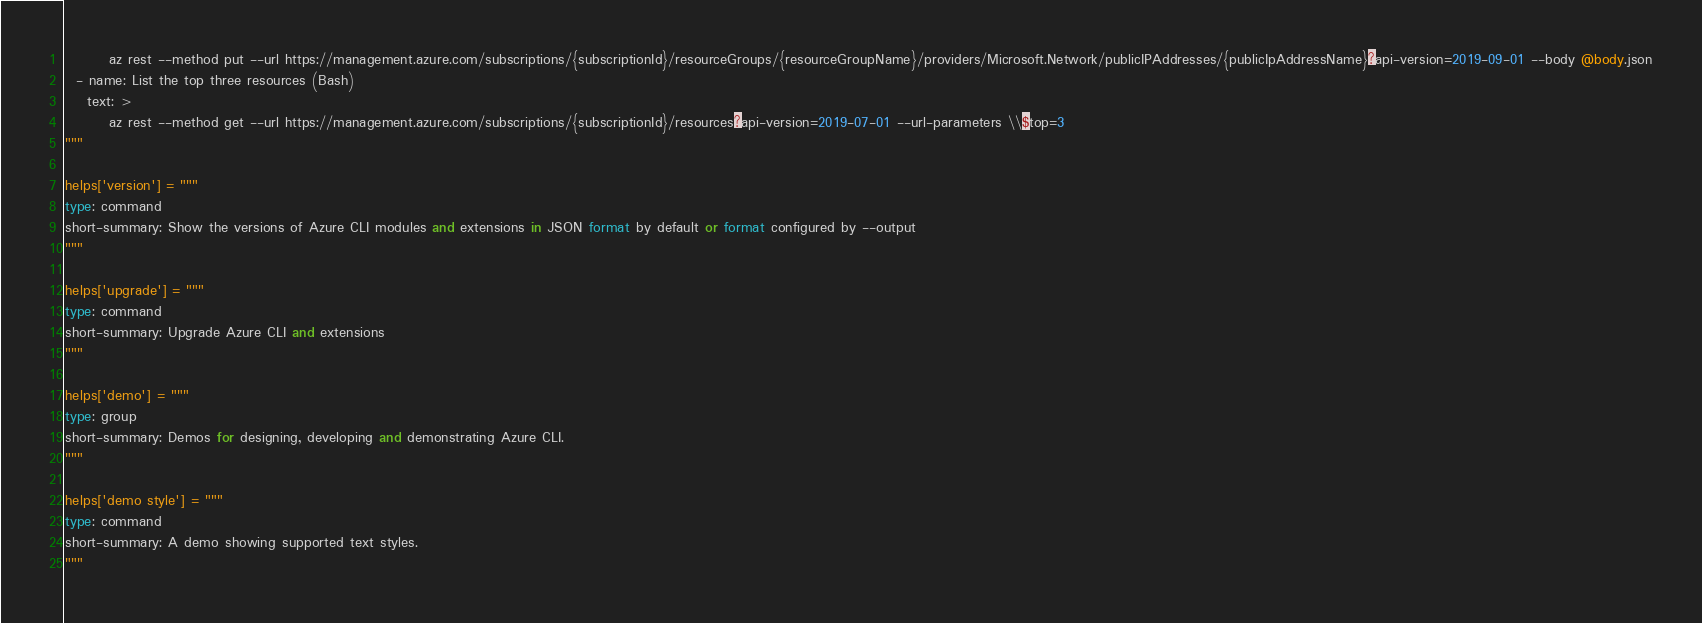<code> <loc_0><loc_0><loc_500><loc_500><_Python_>        az rest --method put --url https://management.azure.com/subscriptions/{subscriptionId}/resourceGroups/{resourceGroupName}/providers/Microsoft.Network/publicIPAddresses/{publicIpAddressName}?api-version=2019-09-01 --body @body.json
  - name: List the top three resources (Bash)
    text: >
        az rest --method get --url https://management.azure.com/subscriptions/{subscriptionId}/resources?api-version=2019-07-01 --url-parameters \\$top=3
"""

helps['version'] = """
type: command
short-summary: Show the versions of Azure CLI modules and extensions in JSON format by default or format configured by --output
"""

helps['upgrade'] = """
type: command
short-summary: Upgrade Azure CLI and extensions
"""

helps['demo'] = """
type: group
short-summary: Demos for designing, developing and demonstrating Azure CLI.
"""

helps['demo style'] = """
type: command
short-summary: A demo showing supported text styles.
"""
</code> 